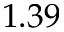Convert formula to latex. <formula><loc_0><loc_0><loc_500><loc_500>1 . 3 9</formula> 